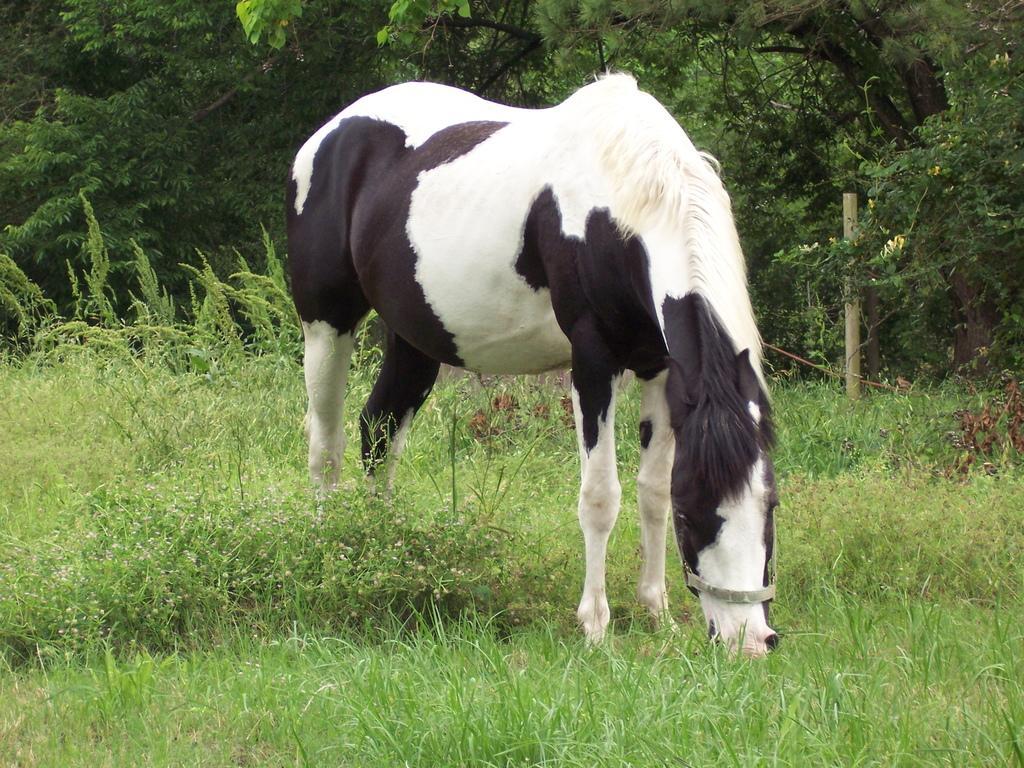In one or two sentences, can you explain what this image depicts? In this image there is a horse on the surface of the grass. In the background there are trees and there is a wooden stick. 